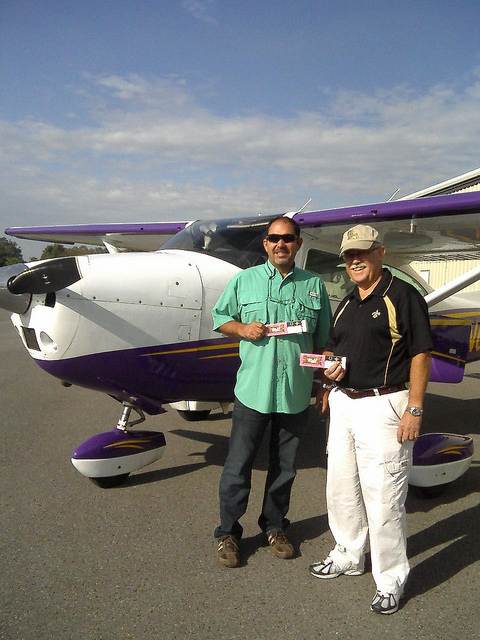How many people are in the photo? There are two individuals present in the photo, both standing on the tarmac beside a small, purple and white airplane, possibly having just finished a flight or preparing for one. They appear to be sharing a joyful moment, as suggested by their open, friendly postures and smiles. 